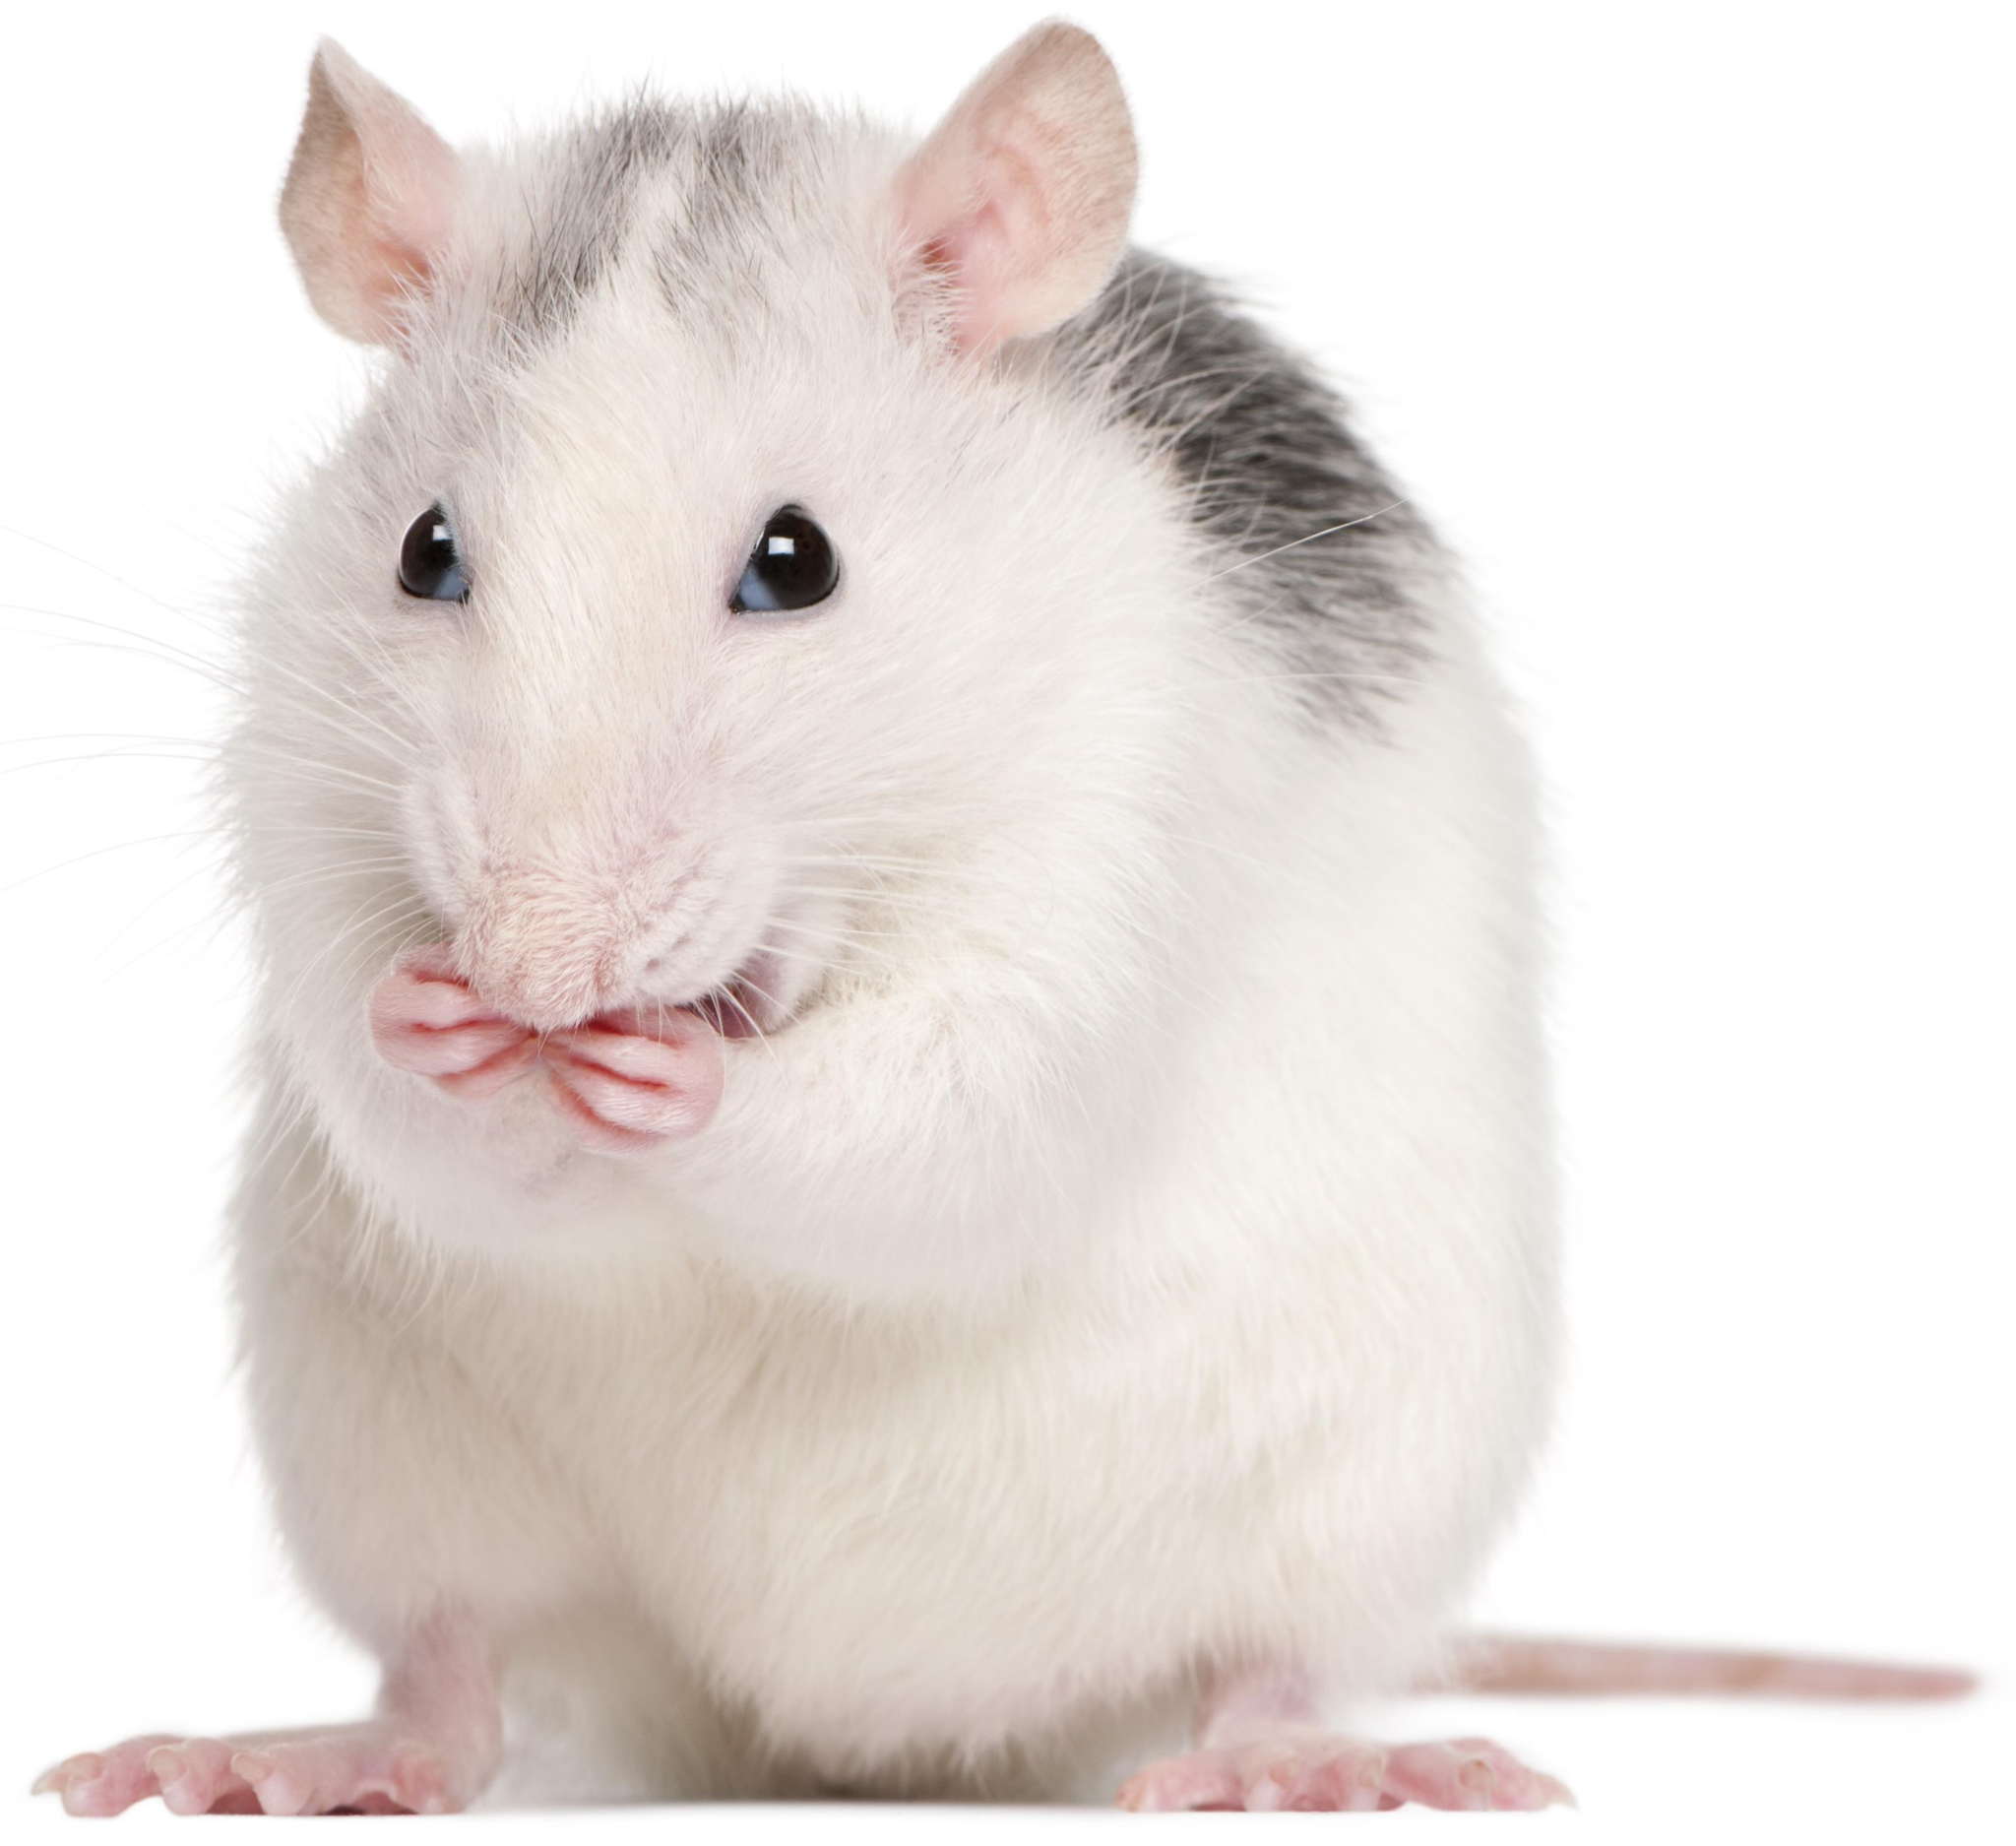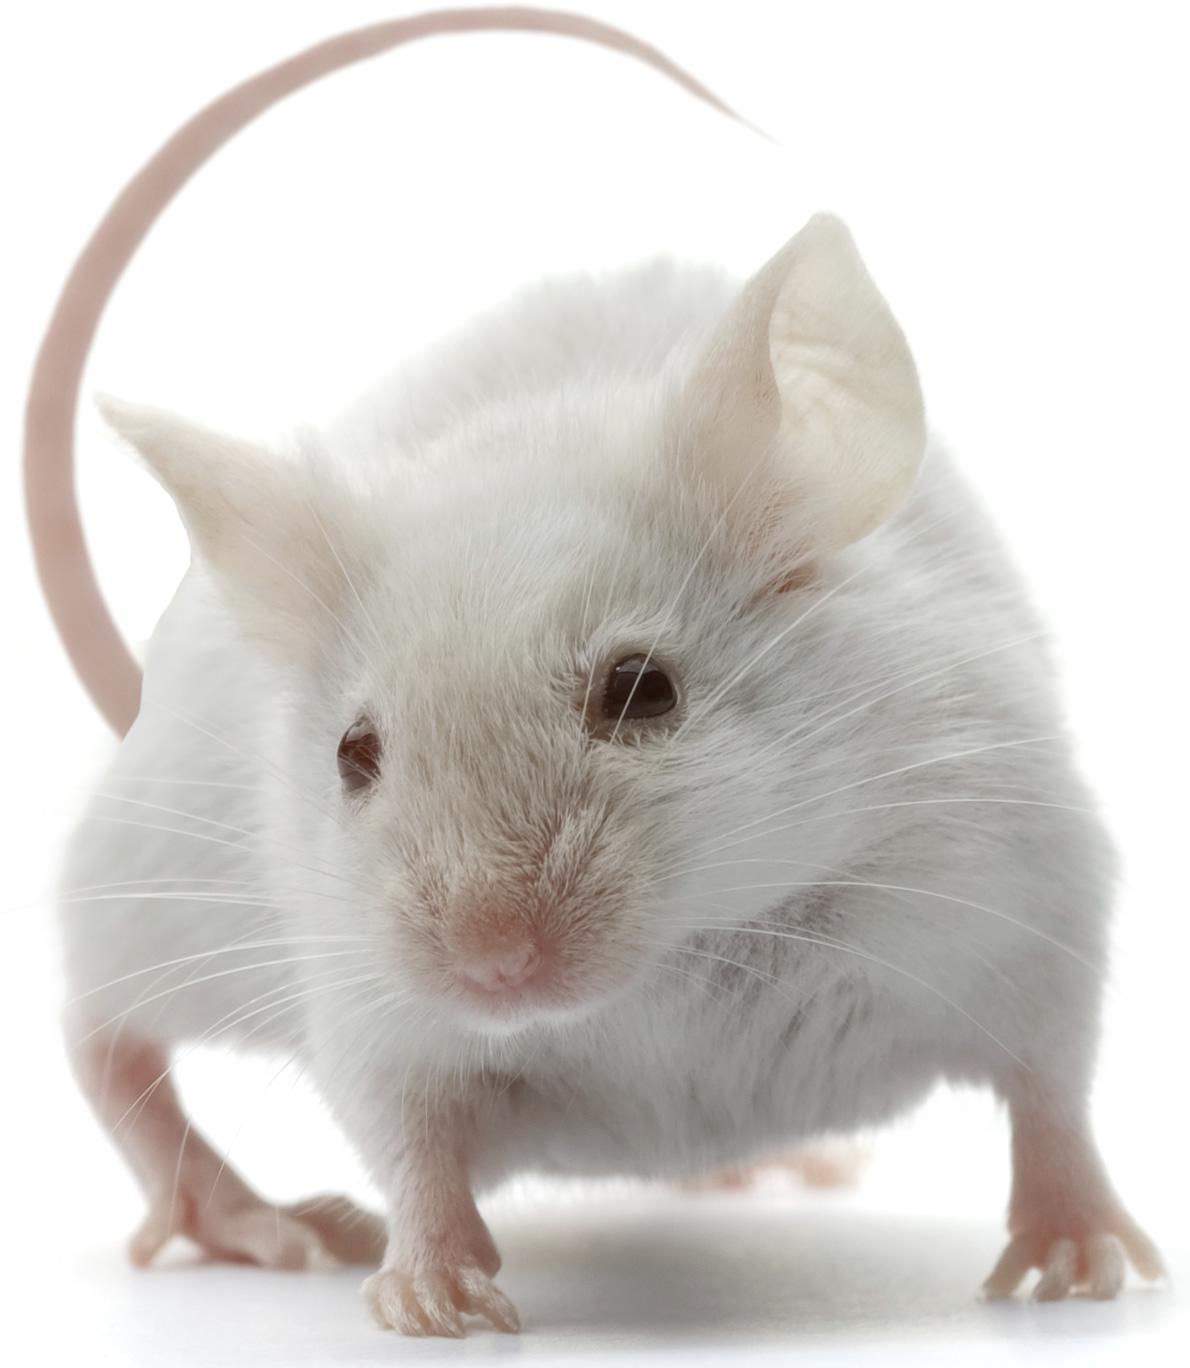The first image is the image on the left, the second image is the image on the right. Assess this claim about the two images: "There is a mouse that is all white in color.". Correct or not? Answer yes or no. Yes. The first image is the image on the left, the second image is the image on the right. Considering the images on both sides, is "the animal in the image on the right is on all fours" valid? Answer yes or no. Yes. 